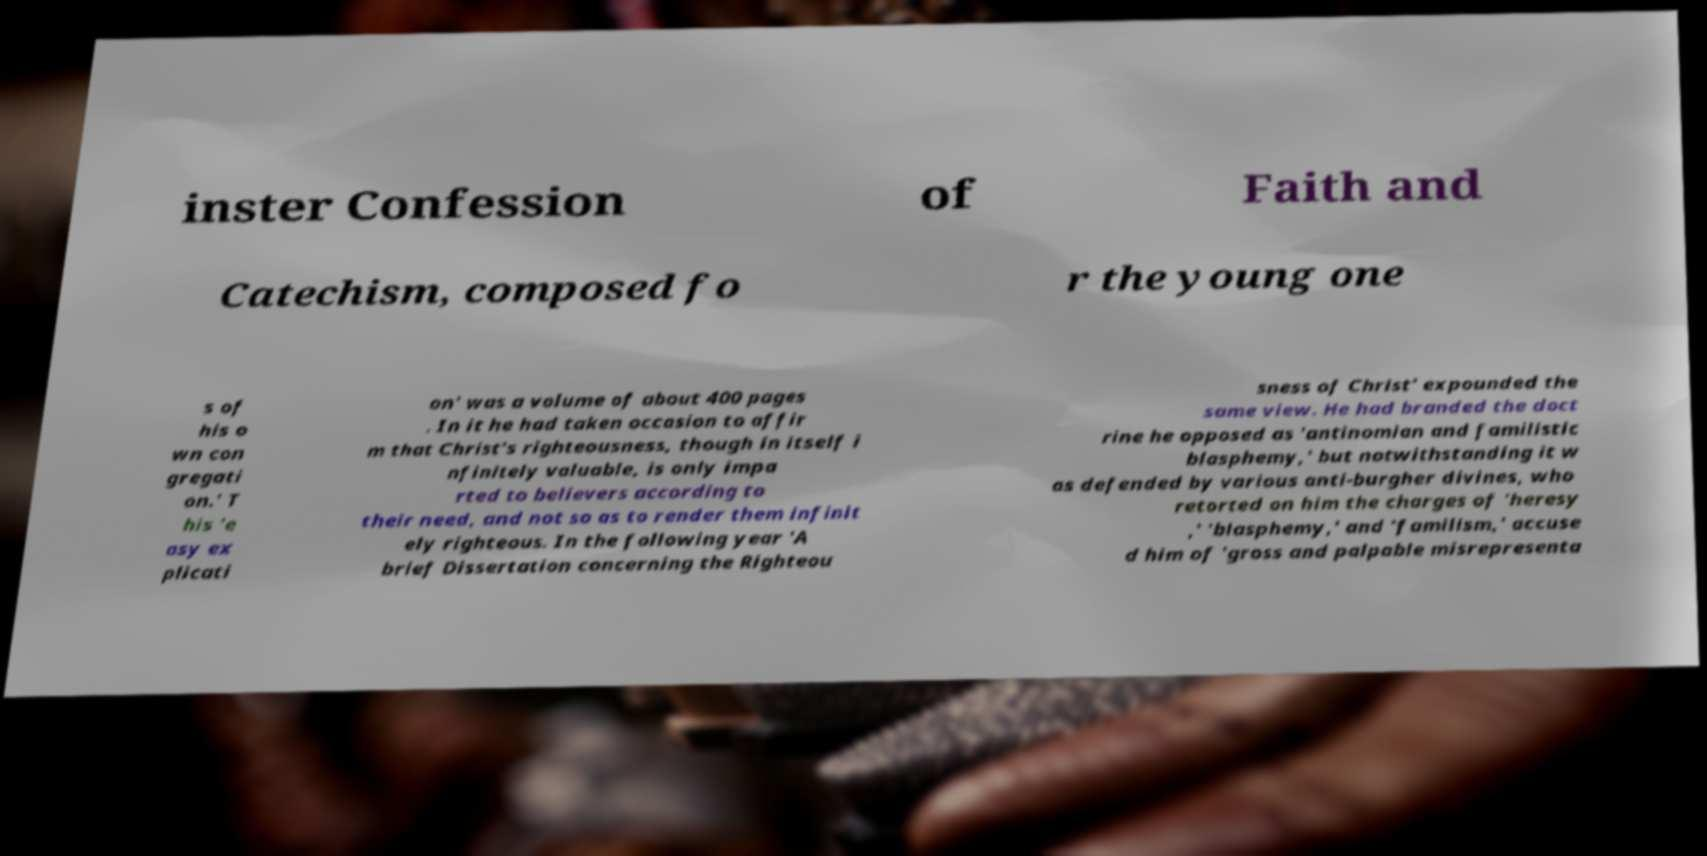Please read and relay the text visible in this image. What does it say? inster Confession of Faith and Catechism, composed fo r the young one s of his o wn con gregati on.' T his 'e asy ex plicati on' was a volume of about 400 pages . In it he had taken occasion to affir m that Christ's righteousness, though in itself i nfinitely valuable, is only impa rted to believers according to their need, and not so as to render them infinit ely righteous. In the following year 'A brief Dissertation concerning the Righteou sness of Christ' expounded the same view. He had branded the doct rine he opposed as 'antinomian and familistic blasphemy,' but notwithstanding it w as defended by various anti-burgher divines, who retorted on him the charges of 'heresy ,' 'blasphemy,' and 'familism,' accuse d him of 'gross and palpable misrepresenta 